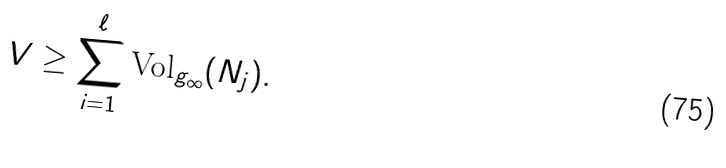Convert formula to latex. <formula><loc_0><loc_0><loc_500><loc_500>V \geq \sum _ { i = 1 } ^ { \ell } \text {Vol} _ { g _ { \infty } } ( N _ { j } ) .</formula> 